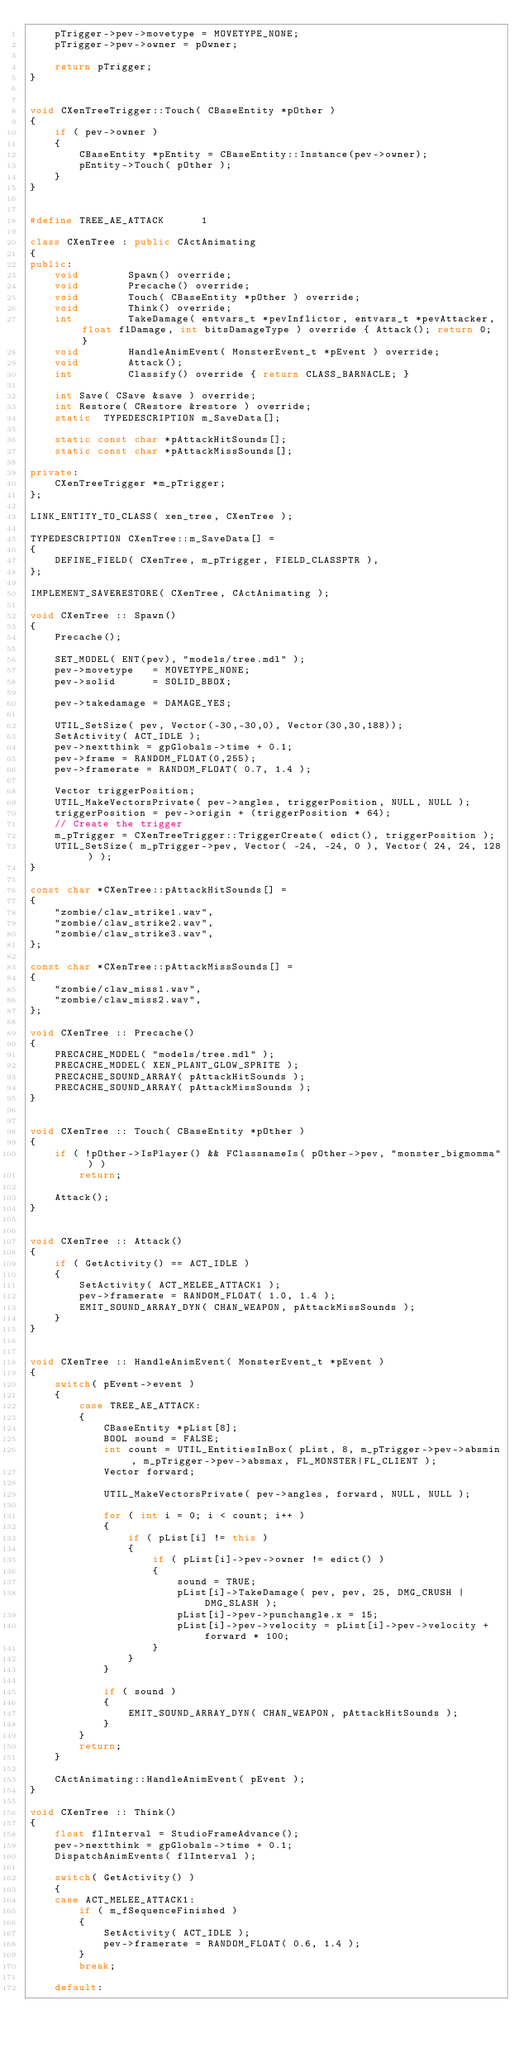Convert code to text. <code><loc_0><loc_0><loc_500><loc_500><_C++_>	pTrigger->pev->movetype = MOVETYPE_NONE;
	pTrigger->pev->owner = pOwner;

	return pTrigger;
}


void CXenTreeTrigger::Touch( CBaseEntity *pOther )
{
	if ( pev->owner )
	{
		CBaseEntity *pEntity = CBaseEntity::Instance(pev->owner);
		pEntity->Touch( pOther );
	}
}


#define TREE_AE_ATTACK		1

class CXenTree : public CActAnimating
{
public:
	void		Spawn() override;
	void		Precache() override;
	void		Touch( CBaseEntity *pOther ) override;
	void		Think() override;
	int			TakeDamage( entvars_t *pevInflictor, entvars_t *pevAttacker, float flDamage, int bitsDamageType ) override { Attack(); return 0; }
	void		HandleAnimEvent( MonsterEvent_t *pEvent ) override;
	void		Attack();
	int			Classify() override { return CLASS_BARNACLE; }

	int	Save( CSave &save ) override;
	int	Restore( CRestore &restore ) override;
	static	TYPEDESCRIPTION m_SaveData[];

	static const char *pAttackHitSounds[];
	static const char *pAttackMissSounds[];

private:
	CXenTreeTrigger	*m_pTrigger;
};

LINK_ENTITY_TO_CLASS( xen_tree, CXenTree );

TYPEDESCRIPTION	CXenTree::m_SaveData[] = 
{
	DEFINE_FIELD( CXenTree, m_pTrigger, FIELD_CLASSPTR ),
};

IMPLEMENT_SAVERESTORE( CXenTree, CActAnimating );

void CXenTree :: Spawn()
{
	Precache();

	SET_MODEL( ENT(pev), "models/tree.mdl" );
	pev->movetype	= MOVETYPE_NONE;
	pev->solid		= SOLID_BBOX;

	pev->takedamage = DAMAGE_YES;

	UTIL_SetSize( pev, Vector(-30,-30,0), Vector(30,30,188));
	SetActivity( ACT_IDLE );
	pev->nextthink = gpGlobals->time + 0.1;
	pev->frame = RANDOM_FLOAT(0,255);
	pev->framerate = RANDOM_FLOAT( 0.7, 1.4 );

	Vector triggerPosition;
	UTIL_MakeVectorsPrivate( pev->angles, triggerPosition, NULL, NULL );
	triggerPosition = pev->origin + (triggerPosition * 64);
	// Create the trigger
	m_pTrigger = CXenTreeTrigger::TriggerCreate( edict(), triggerPosition );
	UTIL_SetSize( m_pTrigger->pev, Vector( -24, -24, 0 ), Vector( 24, 24, 128 ) );
}

const char *CXenTree::pAttackHitSounds[] = 
{
	"zombie/claw_strike1.wav",
	"zombie/claw_strike2.wav",
	"zombie/claw_strike3.wav",
};

const char *CXenTree::pAttackMissSounds[] = 
{
	"zombie/claw_miss1.wav",
	"zombie/claw_miss2.wav",
};

void CXenTree :: Precache()
{
	PRECACHE_MODEL( "models/tree.mdl" );
	PRECACHE_MODEL( XEN_PLANT_GLOW_SPRITE );
	PRECACHE_SOUND_ARRAY( pAttackHitSounds );
	PRECACHE_SOUND_ARRAY( pAttackMissSounds );
}


void CXenTree :: Touch( CBaseEntity *pOther )
{
	if ( !pOther->IsPlayer() && FClassnameIs( pOther->pev, "monster_bigmomma" ) )
		return;

	Attack();
}


void CXenTree :: Attack()
{
	if ( GetActivity() == ACT_IDLE )
	{
		SetActivity( ACT_MELEE_ATTACK1 );
		pev->framerate = RANDOM_FLOAT( 1.0, 1.4 );
		EMIT_SOUND_ARRAY_DYN( CHAN_WEAPON, pAttackMissSounds );
	}
}


void CXenTree :: HandleAnimEvent( MonsterEvent_t *pEvent )
{
	switch( pEvent->event )
	{
		case TREE_AE_ATTACK:
		{
			CBaseEntity *pList[8];
			BOOL sound = FALSE;
			int count = UTIL_EntitiesInBox( pList, 8, m_pTrigger->pev->absmin, m_pTrigger->pev->absmax, FL_MONSTER|FL_CLIENT );
			Vector forward;

			UTIL_MakeVectorsPrivate( pev->angles, forward, NULL, NULL );

			for ( int i = 0; i < count; i++ )
			{
				if ( pList[i] != this )
				{
					if ( pList[i]->pev->owner != edict() )
					{
						sound = TRUE;
						pList[i]->TakeDamage( pev, pev, 25, DMG_CRUSH | DMG_SLASH );
						pList[i]->pev->punchangle.x = 15;
						pList[i]->pev->velocity = pList[i]->pev->velocity + forward * 100;
					}
				}
			}
					
			if ( sound )
			{
				EMIT_SOUND_ARRAY_DYN( CHAN_WEAPON, pAttackHitSounds );
			}
		}
		return;
	}

	CActAnimating::HandleAnimEvent( pEvent );
}

void CXenTree :: Think()
{
	float flInterval = StudioFrameAdvance();
	pev->nextthink = gpGlobals->time + 0.1;
	DispatchAnimEvents( flInterval );

	switch( GetActivity() )
	{
	case ACT_MELEE_ATTACK1:
		if ( m_fSequenceFinished )
		{
			SetActivity( ACT_IDLE );
			pev->framerate = RANDOM_FLOAT( 0.6, 1.4 );
		}
		break;

	default:</code> 